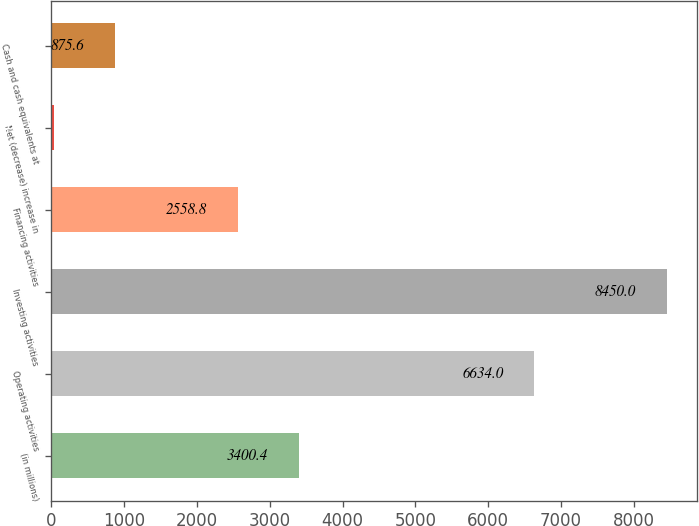Convert chart. <chart><loc_0><loc_0><loc_500><loc_500><bar_chart><fcel>(in millions)<fcel>Operating activities<fcel>Investing activities<fcel>Financing activities<fcel>Net (decrease) increase in<fcel>Cash and cash equivalents at<nl><fcel>3400.4<fcel>6634<fcel>8450<fcel>2558.8<fcel>34<fcel>875.6<nl></chart> 